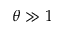<formula> <loc_0><loc_0><loc_500><loc_500>\theta \gg 1</formula> 